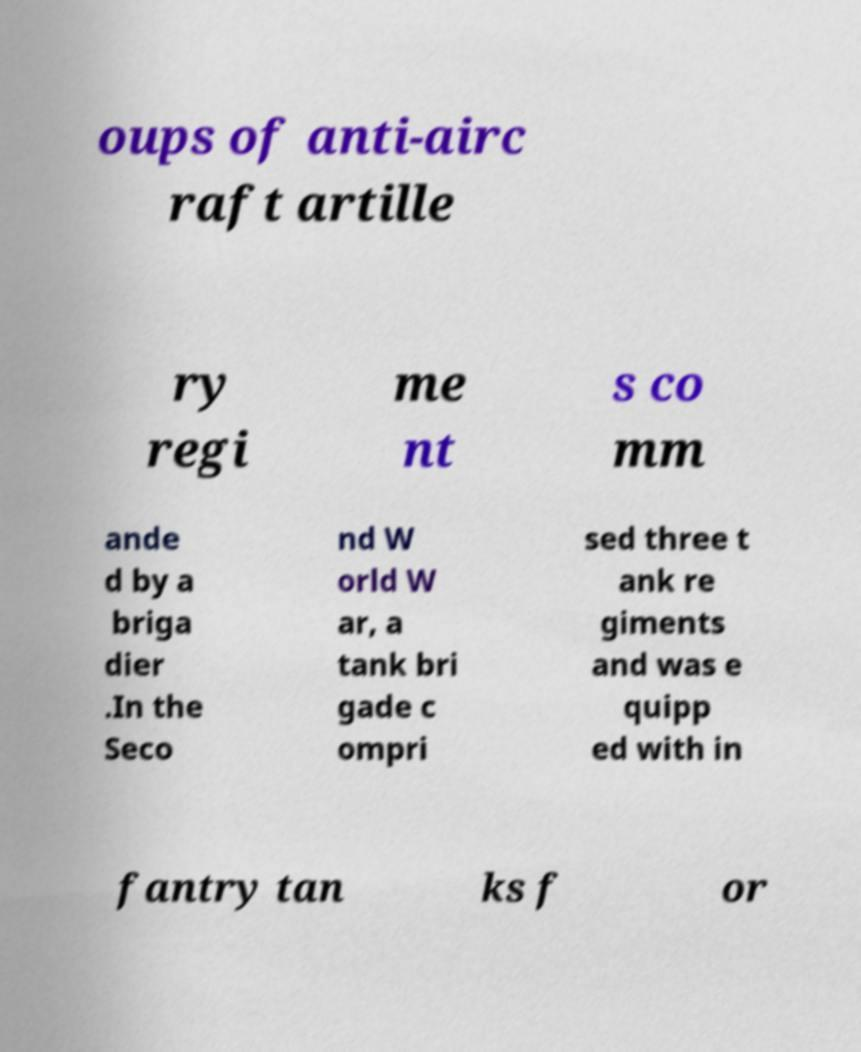Can you read and provide the text displayed in the image?This photo seems to have some interesting text. Can you extract and type it out for me? oups of anti-airc raft artille ry regi me nt s co mm ande d by a briga dier .In the Seco nd W orld W ar, a tank bri gade c ompri sed three t ank re giments and was e quipp ed with in fantry tan ks f or 